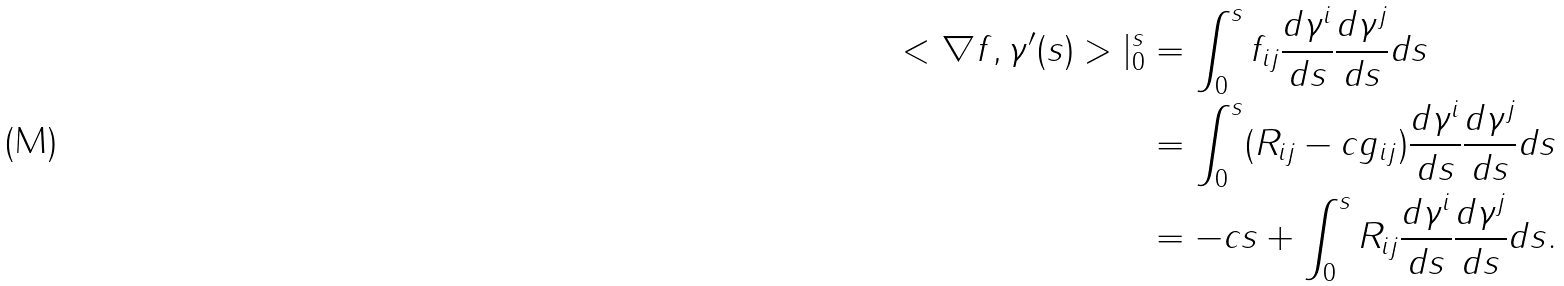<formula> <loc_0><loc_0><loc_500><loc_500>< \nabla f , \gamma ^ { \prime } ( s ) > | _ { 0 } ^ { s } & = \int _ { 0 } ^ { s } f _ { i j } \frac { d \gamma ^ { i } } { d s } \frac { d \gamma ^ { j } } { d s } d s \\ & = \int _ { 0 } ^ { s } ( R _ { i j } - c g _ { i j } ) \frac { d \gamma ^ { i } } { d s } \frac { d \gamma ^ { j } } { d s } d s \\ & = - c s + \int _ { 0 } ^ { s } R _ { i j } \frac { d \gamma ^ { i } } { d s } \frac { d \gamma ^ { j } } { d s } d s .</formula> 